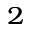Convert formula to latex. <formula><loc_0><loc_0><loc_500><loc_500>^ { 2 }</formula> 